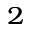Convert formula to latex. <formula><loc_0><loc_0><loc_500><loc_500>^ { 2 }</formula> 